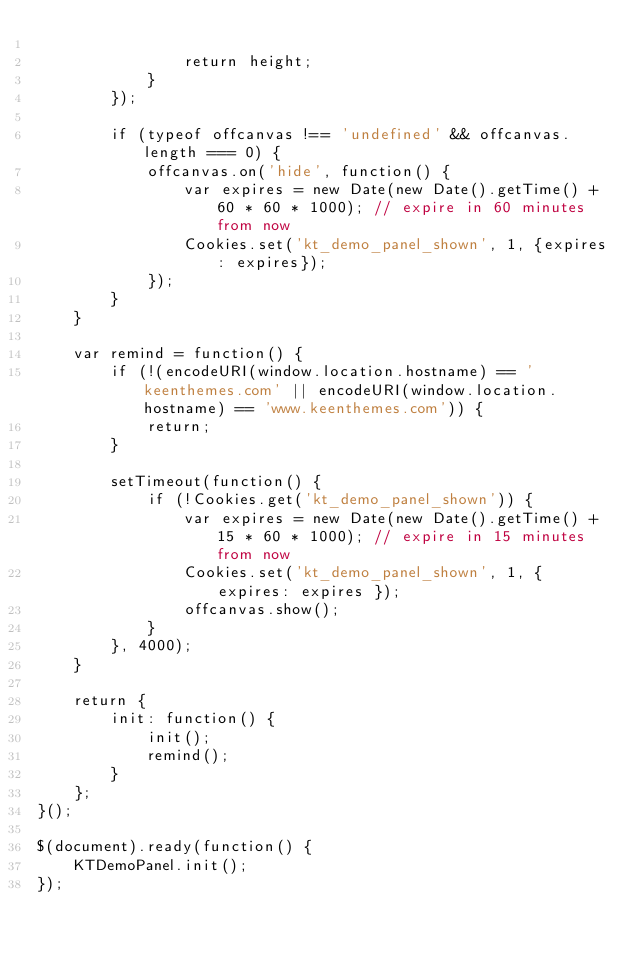Convert code to text. <code><loc_0><loc_0><loc_500><loc_500><_JavaScript_>
                return height;
            }
        });

        if (typeof offcanvas !== 'undefined' && offcanvas.length === 0) {
            offcanvas.on('hide', function() {
                var expires = new Date(new Date().getTime() + 60 * 60 * 1000); // expire in 60 minutes from now
                Cookies.set('kt_demo_panel_shown', 1, {expires: expires});
            });
        }
    }

    var remind = function() {
        if (!(encodeURI(window.location.hostname) == 'keenthemes.com' || encodeURI(window.location.hostname) == 'www.keenthemes.com')) {
            return;
        }

        setTimeout(function() {
            if (!Cookies.get('kt_demo_panel_shown')) {
                var expires = new Date(new Date().getTime() + 15 * 60 * 1000); // expire in 15 minutes from now
                Cookies.set('kt_demo_panel_shown', 1, { expires: expires });
                offcanvas.show();
            } 
        }, 4000);
    }

    return {     
        init: function() {  
            init(); 
            remind();
        }
    };
}();

$(document).ready(function() {
    KTDemoPanel.init();
});</code> 